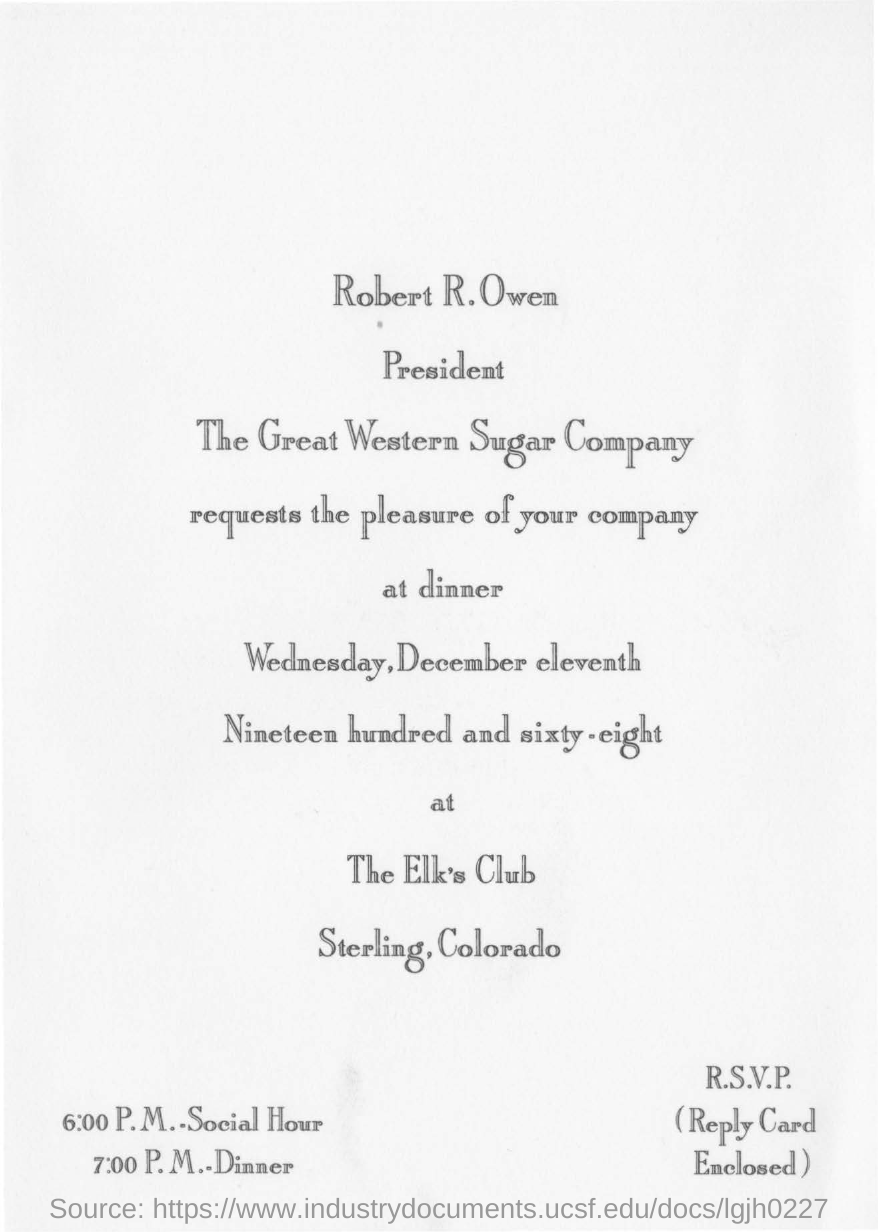What is this letter about?
Offer a very short reply. Invitation for dinner. What is the dinner date mentioned here?
Provide a succinct answer. Wednesday,December eleventh Nineteen hundred and sixty-eight. What is the venue of the dinner?
Your answer should be very brief. The Elk's Club Sterling,Colorado. What is the time of social hour?
Provide a short and direct response. 6:00 P.M. When was the dinner scheduled?
Give a very brief answer. 7:00 P.M. 